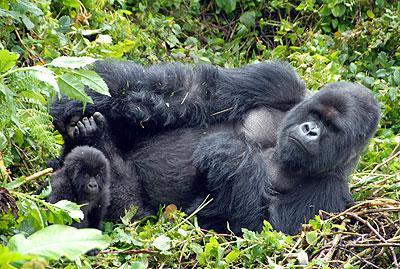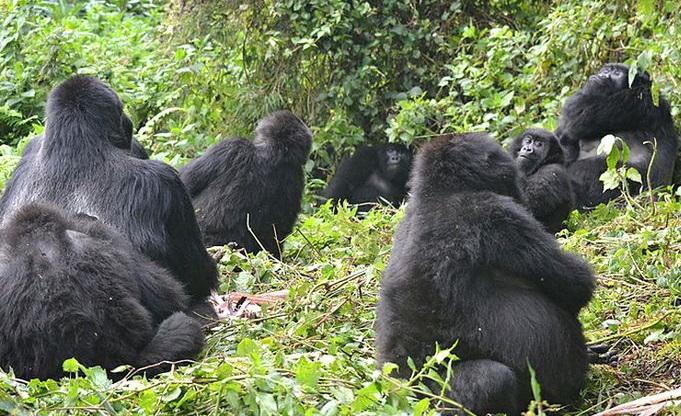The first image is the image on the left, the second image is the image on the right. For the images shown, is this caption "An image containing exactly two gorillas includes a male gorilla on all fours moving toward the camera." true? Answer yes or no. No. The first image is the image on the left, the second image is the image on the right. For the images displayed, is the sentence "There are exactly five gorillas." factually correct? Answer yes or no. No. 